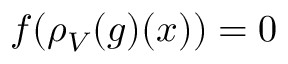Convert formula to latex. <formula><loc_0><loc_0><loc_500><loc_500>f ( \rho _ { V } ( g ) ( x ) ) = 0</formula> 